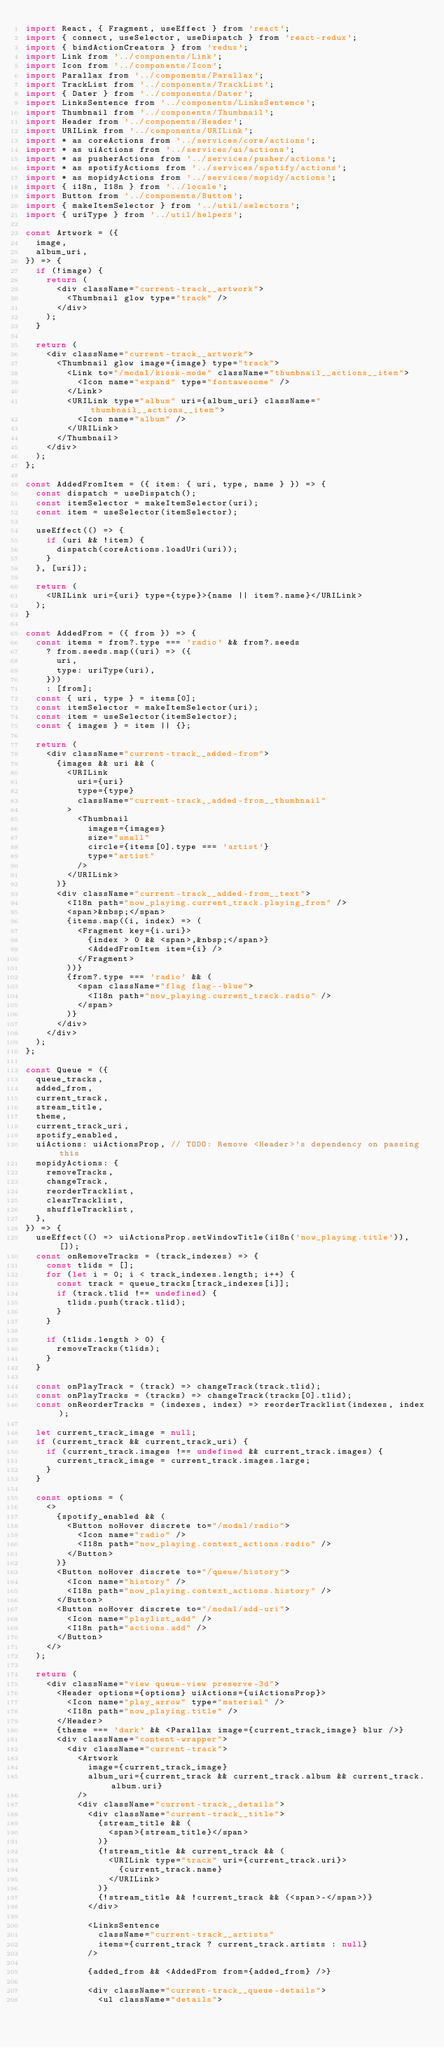Convert code to text. <code><loc_0><loc_0><loc_500><loc_500><_JavaScript_>import React, { Fragment, useEffect } from 'react';
import { connect, useSelector, useDispatch } from 'react-redux';
import { bindActionCreators } from 'redux';
import Link from '../components/Link';
import Icon from '../components/Icon';
import Parallax from '../components/Parallax';
import TrackList from '../components/TrackList';
import { Dater } from '../components/Dater';
import LinksSentence from '../components/LinksSentence';
import Thumbnail from '../components/Thumbnail';
import Header from '../components/Header';
import URILink from '../components/URILink';
import * as coreActions from '../services/core/actions';
import * as uiActions from '../services/ui/actions';
import * as pusherActions from '../services/pusher/actions';
import * as spotifyActions from '../services/spotify/actions';
import * as mopidyActions from '../services/mopidy/actions';
import { i18n, I18n } from '../locale';
import Button from '../components/Button';
import { makeItemSelector } from '../util/selectors';
import { uriType } from '../util/helpers';

const Artwork = ({
  image,
  album_uri,
}) => {
  if (!image) {
    return (
      <div className="current-track__artwork">
        <Thumbnail glow type="track" />
      </div>
    );
  }

  return (
    <div className="current-track__artwork">
      <Thumbnail glow image={image} type="track">
        <Link to="/modal/kiosk-mode" className="thumbnail__actions__item">
          <Icon name="expand" type="fontawesome" />
        </Link>
        <URILink type="album" uri={album_uri} className="thumbnail__actions__item">
          <Icon name="album" />
        </URILink>
      </Thumbnail>
    </div>
  );
};

const AddedFromItem = ({ item: { uri, type, name } }) => {
  const dispatch = useDispatch();
  const itemSelector = makeItemSelector(uri);
  const item = useSelector(itemSelector);

  useEffect(() => {
    if (uri && !item) {
      dispatch(coreActions.loadUri(uri));
    }
  }, [uri]);

  return (
    <URILink uri={uri} type={type}>{name || item?.name}</URILink>
  );
}

const AddedFrom = ({ from }) => {
  const items = from?.type === 'radio' && from?.seeds
    ? from.seeds.map((uri) => ({
      uri,
      type: uriType(uri),
    }))
    : [from];
  const { uri, type } = items[0];
  const itemSelector = makeItemSelector(uri);
  const item = useSelector(itemSelector);
  const { images } = item || {};

  return (
    <div className="current-track__added-from">
      {images && uri && (
        <URILink
          uri={uri}
          type={type}
          className="current-track__added-from__thumbnail"
        >
          <Thumbnail
            images={images}
            size="small"
            circle={items[0].type === 'artist'}
            type="artist"
          />
        </URILink>
      )}
      <div className="current-track__added-from__text">
        <I18n path="now_playing.current_track.playing_from" />
        <span>&nbsp;</span>
        {items.map((i, index) => (
          <Fragment key={i.uri}>
            {index > 0 && <span>,&nbsp;</span>}
            <AddedFromItem item={i} />
          </Fragment>
        ))}
        {from?.type === 'radio' && (
          <span className="flag flag--blue">
            <I18n path="now_playing.current_track.radio" />
          </span>
        )}
      </div>
    </div>
  );
};

const Queue = ({
  queue_tracks,
  added_from,
  current_track,
  stream_title,
  theme,
  current_track_uri,
  spotify_enabled,
  uiActions: uiActionsProp, // TODO: Remove <Header>'s dependency on passing this
  mopidyActions: {
    removeTracks,
    changeTrack,
    reorderTracklist,
    clearTracklist,
    shuffleTracklist,
  },
}) => {
  useEffect(() => uiActionsProp.setWindowTitle(i18n('now_playing.title')), []);
  const onRemoveTracks = (track_indexes) => {
    const tlids = [];
    for (let i = 0; i < track_indexes.length; i++) {
      const track = queue_tracks[track_indexes[i]];
      if (track.tlid !== undefined) {
        tlids.push(track.tlid);
      }
    }

    if (tlids.length > 0) {
      removeTracks(tlids);
    }
  }

  const onPlayTrack = (track) => changeTrack(track.tlid);
  const onPlayTracks = (tracks) => changeTrack(tracks[0].tlid);
  const onReorderTracks = (indexes, index) => reorderTracklist(indexes, index);

  let current_track_image = null;
  if (current_track && current_track_uri) {
    if (current_track.images !== undefined && current_track.images) {
      current_track_image = current_track.images.large;
    }
  }

  const options = (
    <>
      {spotify_enabled && (
        <Button noHover discrete to="/modal/radio">
          <Icon name="radio" />
          <I18n path="now_playing.context_actions.radio" />
        </Button>
      )}
      <Button noHover discrete to="/queue/history">
        <Icon name="history" />
        <I18n path="now_playing.context_actions.history" />
      </Button>
      <Button noHover discrete to="/modal/add-uri">
        <Icon name="playlist_add" />
        <I18n path="actions.add" />
      </Button>
    </>
  );

  return (
    <div className="view queue-view preserve-3d">
      <Header options={options} uiActions={uiActionsProp}>
        <Icon name="play_arrow" type="material" />
        <I18n path="now_playing.title" />
      </Header>
      {theme === 'dark' && <Parallax image={current_track_image} blur />}
      <div className="content-wrapper">
        <div className="current-track">
          <Artwork
            image={current_track_image}
            album_uri={current_track && current_track.album && current_track.album.uri}
          />
          <div className="current-track__details">
            <div className="current-track__title">
              {stream_title && (
                <span>{stream_title}</span>
              )}
              {!stream_title && current_track && (
                <URILink type="track" uri={current_track.uri}>
                  {current_track.name}
                </URILink>
              )}
              {!stream_title && !current_track && (<span>-</span>)}
            </div>

            <LinksSentence
              className="current-track__artists"
              items={current_track ? current_track.artists : null}
            />

            {added_from && <AddedFrom from={added_from} />}

            <div className="current-track__queue-details">
              <ul className="details"></code> 